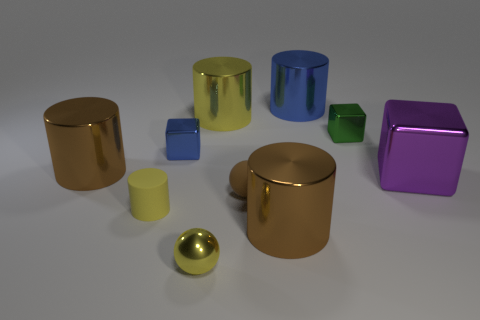Subtract all large cubes. How many cubes are left? 2 Subtract all balls. How many objects are left? 8 Subtract all purple balls. How many brown cylinders are left? 2 Subtract all yellow spheres. How many spheres are left? 1 Subtract 2 cubes. How many cubes are left? 1 Add 7 green things. How many green things exist? 8 Subtract 1 yellow balls. How many objects are left? 9 Subtract all blue cylinders. Subtract all green spheres. How many cylinders are left? 4 Subtract all large brown things. Subtract all yellow rubber things. How many objects are left? 7 Add 1 blue metal blocks. How many blue metal blocks are left? 2 